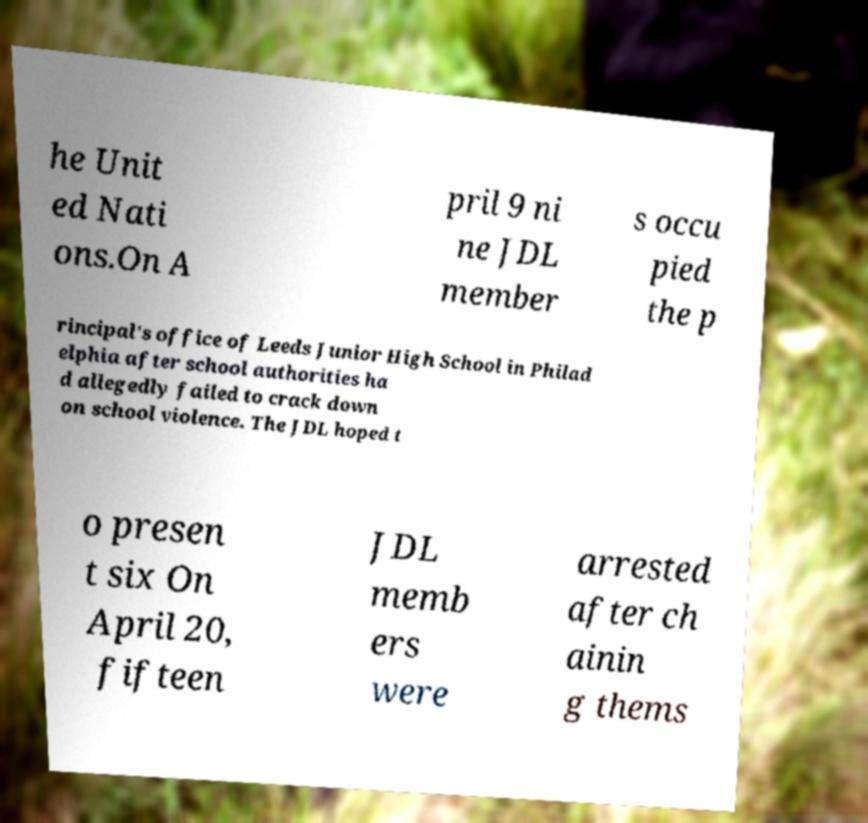Could you assist in decoding the text presented in this image and type it out clearly? he Unit ed Nati ons.On A pril 9 ni ne JDL member s occu pied the p rincipal's office of Leeds Junior High School in Philad elphia after school authorities ha d allegedly failed to crack down on school violence. The JDL hoped t o presen t six On April 20, fifteen JDL memb ers were arrested after ch ainin g thems 